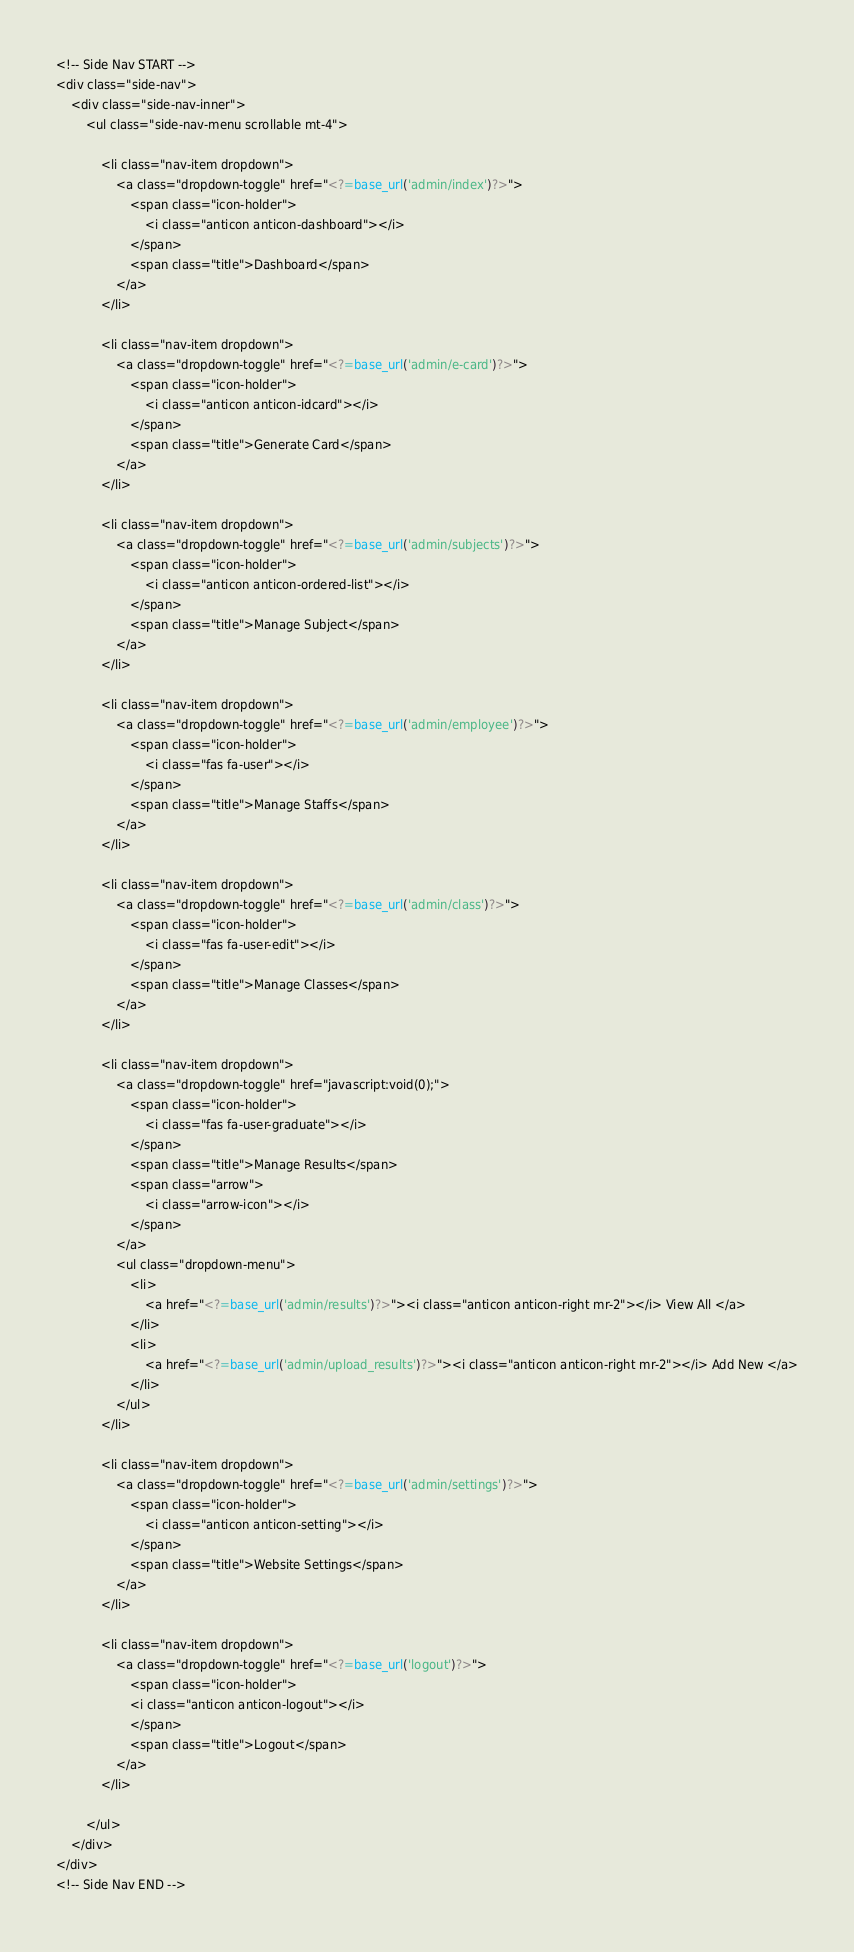<code> <loc_0><loc_0><loc_500><loc_500><_PHP_><!-- Side Nav START -->
<div class="side-nav">
    <div class="side-nav-inner">
        <ul class="side-nav-menu scrollable mt-4">

            <li class="nav-item dropdown">
                <a class="dropdown-toggle" href="<?=base_url('admin/index')?>">
                    <span class="icon-holder">
                        <i class="anticon anticon-dashboard"></i>
                    </span>
                    <span class="title">Dashboard</span>
                </a>
            </li>
            
            <li class="nav-item dropdown">
                <a class="dropdown-toggle" href="<?=base_url('admin/e-card')?>">
                    <span class="icon-holder">
                        <i class="anticon anticon-idcard"></i>
                    </span>
                    <span class="title">Generate Card</span>
                </a>
            </li>
            
            <li class="nav-item dropdown">
                <a class="dropdown-toggle" href="<?=base_url('admin/subjects')?>">
                    <span class="icon-holder">
                        <i class="anticon anticon-ordered-list"></i>
                    </span>
                    <span class="title">Manage Subject</span>
                </a>
            </li>
            
            <li class="nav-item dropdown">
                <a class="dropdown-toggle" href="<?=base_url('admin/employee')?>">
                    <span class="icon-holder">
                        <i class="fas fa-user"></i>
                    </span>
                    <span class="title">Manage Staffs</span>
                </a>
            </li>
            
            <li class="nav-item dropdown">
                <a class="dropdown-toggle" href="<?=base_url('admin/class')?>">
                    <span class="icon-holder">
                        <i class="fas fa-user-edit"></i>
                    </span>
                    <span class="title">Manage Classes</span>
                </a>
            </li>

            <li class="nav-item dropdown">
                <a class="dropdown-toggle" href="javascript:void(0);">
                    <span class="icon-holder">
                        <i class="fas fa-user-graduate"></i>
                    </span>
                    <span class="title">Manage Results</span>
                    <span class="arrow">
                        <i class="arrow-icon"></i>
                    </span>
                </a>
                <ul class="dropdown-menu">
                    <li>
                        <a href="<?=base_url('admin/results')?>"><i class="anticon anticon-right mr-2"></i> View All </a>
                    </li>
                    <li>
                        <a href="<?=base_url('admin/upload_results')?>"><i class="anticon anticon-right mr-2"></i> Add New </a>
                    </li>
                </ul>
            </li>
            
            <li class="nav-item dropdown">
                <a class="dropdown-toggle" href="<?=base_url('admin/settings')?>">
                    <span class="icon-holder">
                        <i class="anticon anticon-setting"></i>
                    </span>
                    <span class="title">Website Settings</span>
                </a>
            </li>
            
            <li class="nav-item dropdown">
                <a class="dropdown-toggle" href="<?=base_url('logout')?>">
                    <span class="icon-holder">
                    <i class="anticon anticon-logout"></i>
                    </span>
                    <span class="title">Logout</span>
                </a>
            </li>

        </ul>
    </div>
</div>
<!-- Side Nav END -->
</code> 